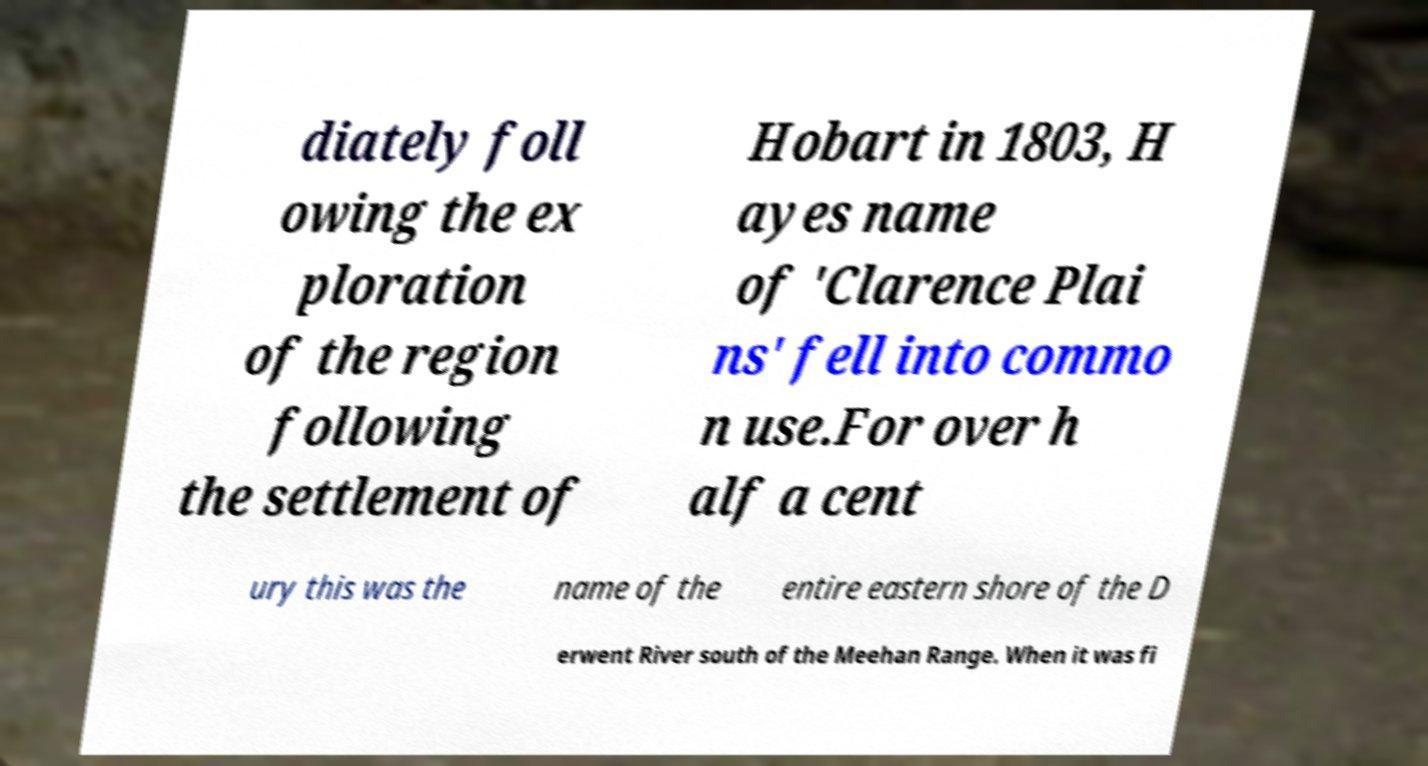Could you extract and type out the text from this image? diately foll owing the ex ploration of the region following the settlement of Hobart in 1803, H ayes name of 'Clarence Plai ns' fell into commo n use.For over h alf a cent ury this was the name of the entire eastern shore of the D erwent River south of the Meehan Range. When it was fi 